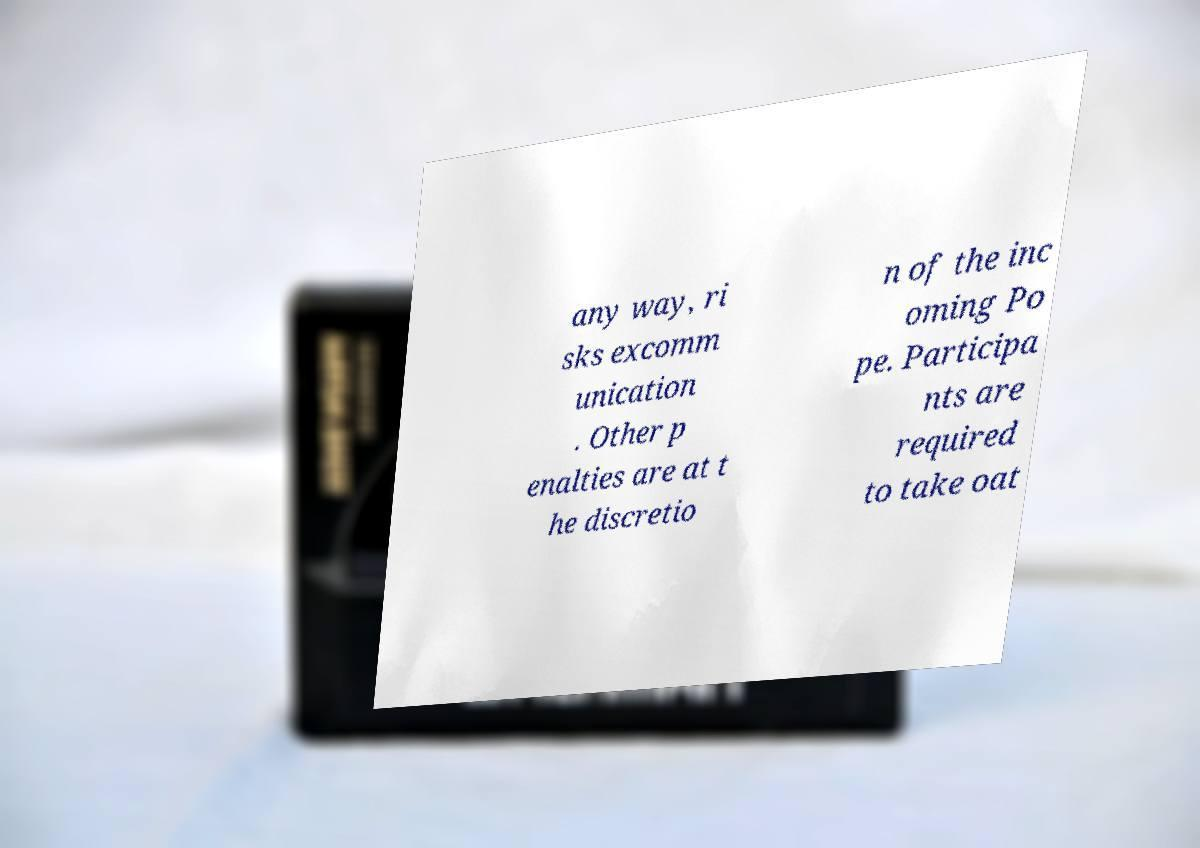For documentation purposes, I need the text within this image transcribed. Could you provide that? any way, ri sks excomm unication . Other p enalties are at t he discretio n of the inc oming Po pe. Participa nts are required to take oat 